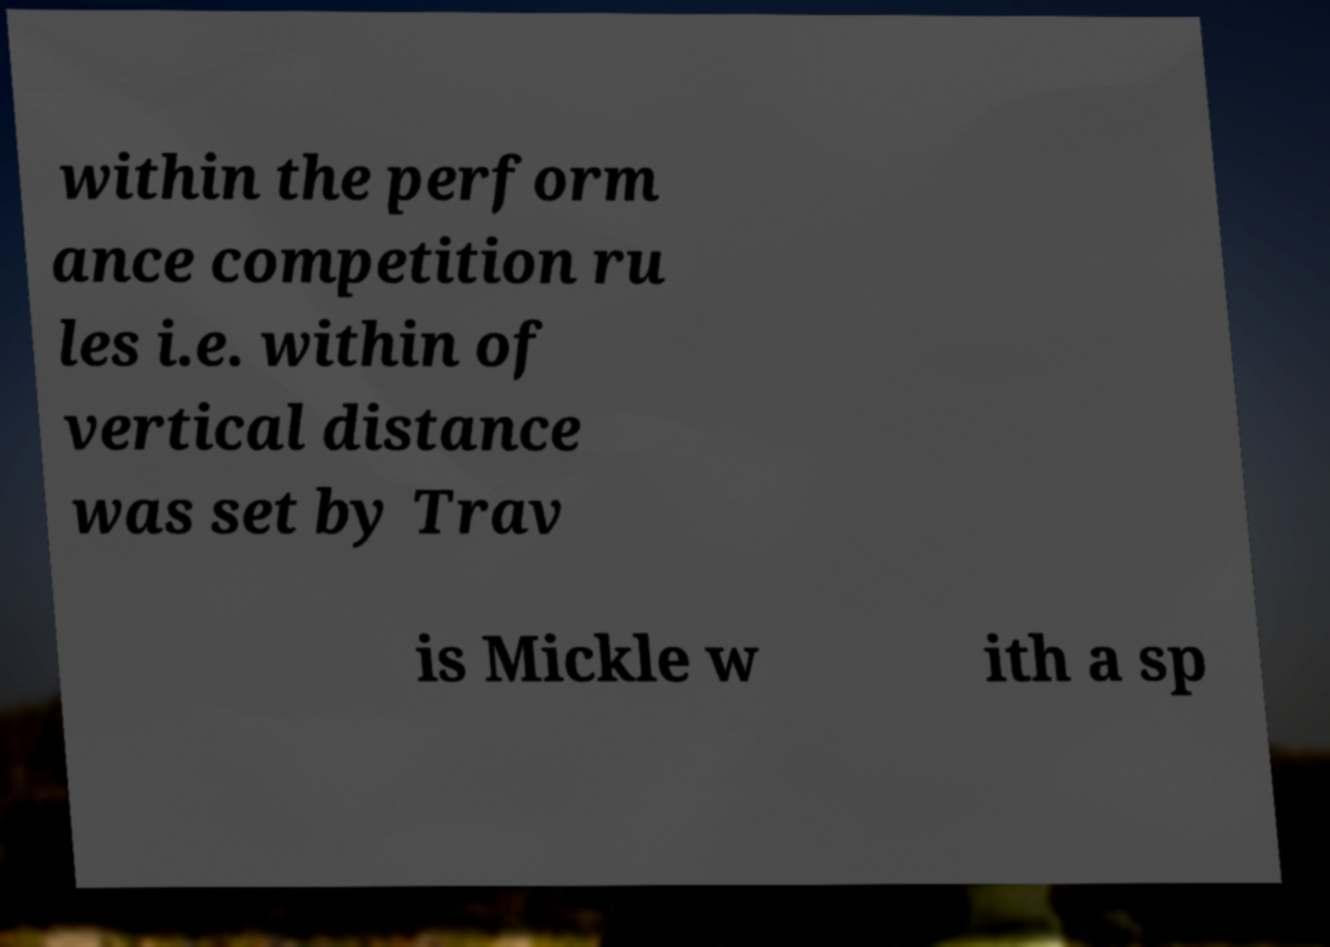What messages or text are displayed in this image? I need them in a readable, typed format. within the perform ance competition ru les i.e. within of vertical distance was set by Trav is Mickle w ith a sp 